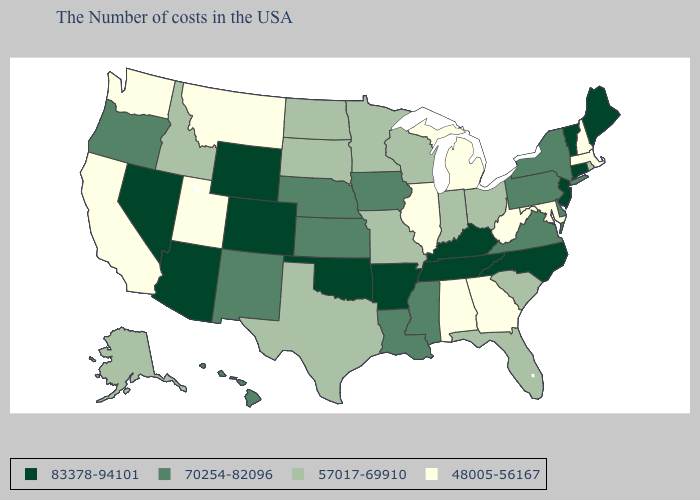What is the value of Kentucky?
Quick response, please. 83378-94101. Name the states that have a value in the range 57017-69910?
Write a very short answer. Rhode Island, South Carolina, Ohio, Florida, Indiana, Wisconsin, Missouri, Minnesota, Texas, South Dakota, North Dakota, Idaho, Alaska. What is the highest value in the USA?
Concise answer only. 83378-94101. Name the states that have a value in the range 70254-82096?
Concise answer only. New York, Delaware, Pennsylvania, Virginia, Mississippi, Louisiana, Iowa, Kansas, Nebraska, New Mexico, Oregon, Hawaii. Name the states that have a value in the range 83378-94101?
Quick response, please. Maine, Vermont, Connecticut, New Jersey, North Carolina, Kentucky, Tennessee, Arkansas, Oklahoma, Wyoming, Colorado, Arizona, Nevada. Name the states that have a value in the range 70254-82096?
Short answer required. New York, Delaware, Pennsylvania, Virginia, Mississippi, Louisiana, Iowa, Kansas, Nebraska, New Mexico, Oregon, Hawaii. What is the value of Washington?
Concise answer only. 48005-56167. What is the value of Connecticut?
Give a very brief answer. 83378-94101. Which states hav the highest value in the MidWest?
Write a very short answer. Iowa, Kansas, Nebraska. Name the states that have a value in the range 48005-56167?
Write a very short answer. Massachusetts, New Hampshire, Maryland, West Virginia, Georgia, Michigan, Alabama, Illinois, Utah, Montana, California, Washington. Does Alabama have the highest value in the USA?
Give a very brief answer. No. What is the value of Oregon?
Write a very short answer. 70254-82096. Among the states that border Massachusetts , does New York have the highest value?
Short answer required. No. Among the states that border Minnesota , which have the lowest value?
Keep it brief. Wisconsin, South Dakota, North Dakota. 